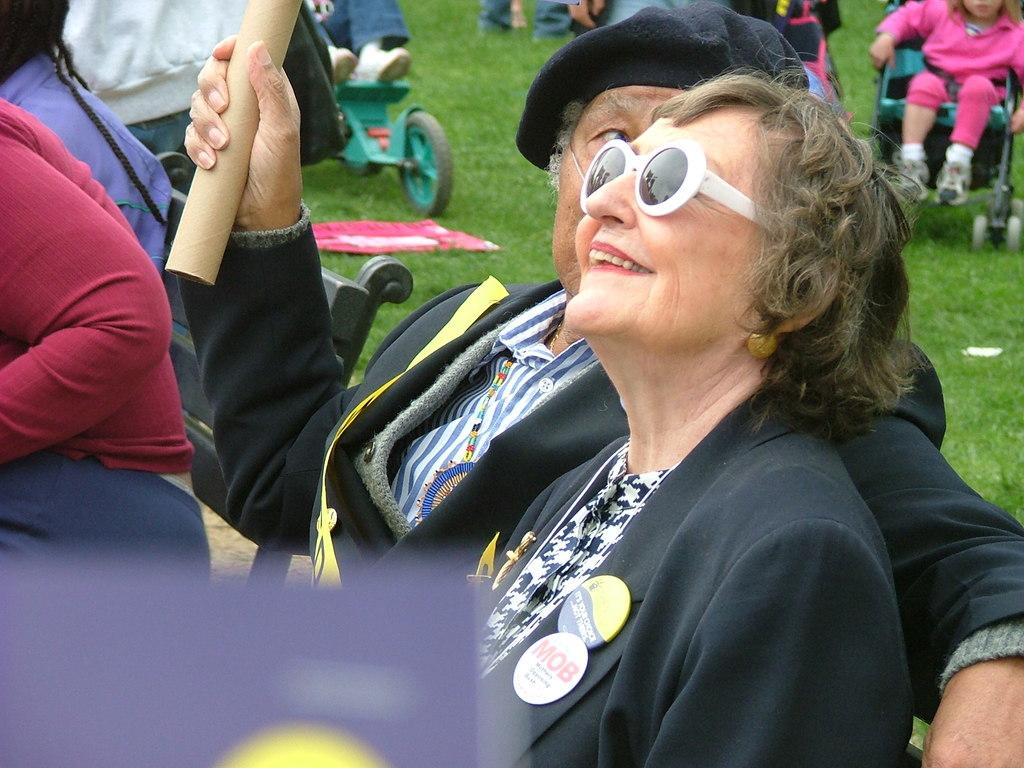Who or what can be seen in the image? There are people in the image. What is the ground covered with? The ground is covered with grass. Can you describe the object in the image? Unfortunately, the facts provided do not give any information about the object in the image. What are baby trolleys used for? Baby trolleys are used for transporting babies or small children. Where can people sit in the image? There is a bench in the image where people can sit. What type of berry is growing on the bench in the image? There is no berry growing on the bench in the image. 